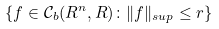Convert formula to latex. <formula><loc_0><loc_0><loc_500><loc_500>\{ f \in \mathcal { C } _ { b } ( { R } ^ { n } , { R } ) \colon \| f \| _ { s u p } \leq r \}</formula> 